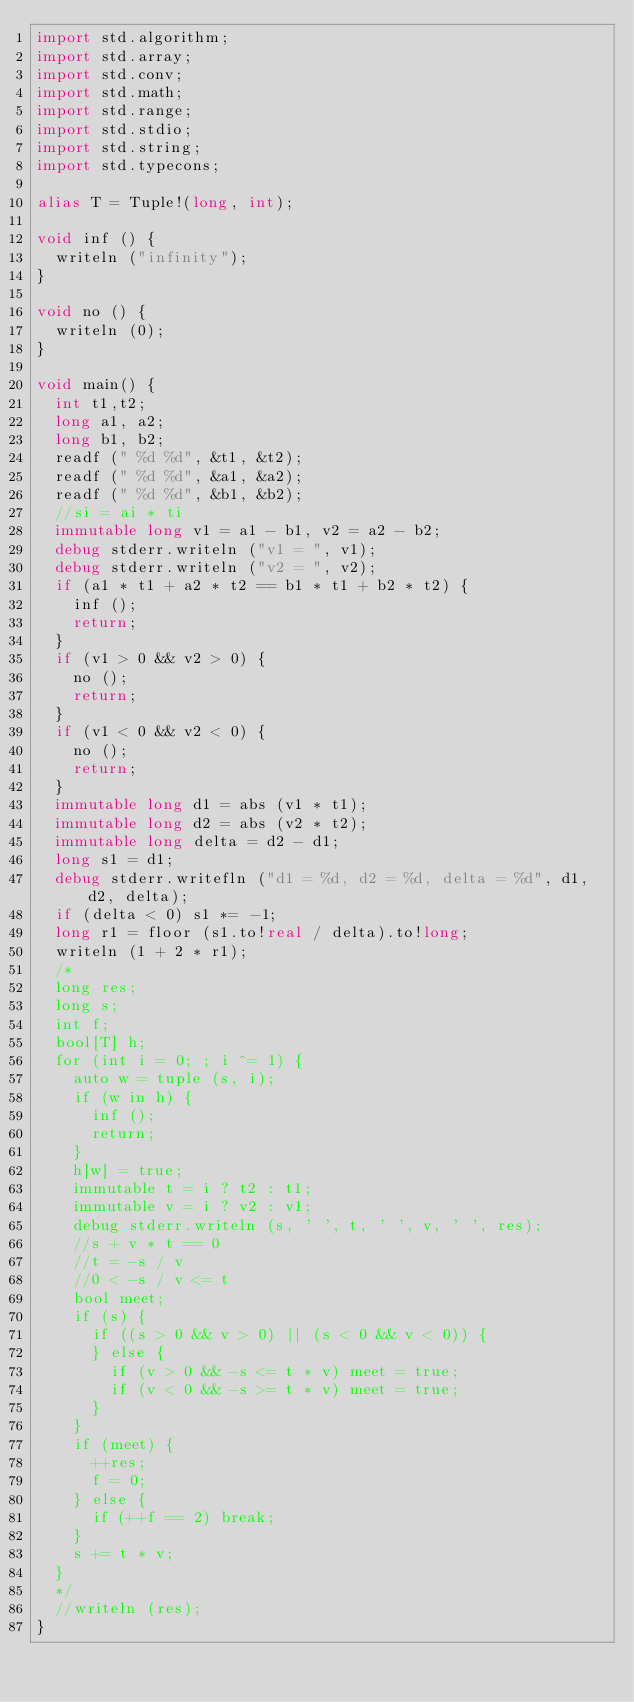Convert code to text. <code><loc_0><loc_0><loc_500><loc_500><_D_>import std.algorithm;
import std.array;
import std.conv;
import std.math;
import std.range;
import std.stdio;
import std.string;
import std.typecons;

alias T = Tuple!(long, int);

void inf () {
  writeln ("infinity");
}

void no () {
  writeln (0);
}

void main() {
  int t1,t2;
  long a1, a2;
  long b1, b2;
  readf (" %d %d", &t1, &t2);
  readf (" %d %d", &a1, &a2);
  readf (" %d %d", &b1, &b2);
  //si = ai * ti
  immutable long v1 = a1 - b1, v2 = a2 - b2;
  debug stderr.writeln ("v1 = ", v1);
  debug stderr.writeln ("v2 = ", v2);
  if (a1 * t1 + a2 * t2 == b1 * t1 + b2 * t2) {
    inf ();
    return;
  }
  if (v1 > 0 && v2 > 0) {
    no ();
    return;
  }
  if (v1 < 0 && v2 < 0) {
    no ();
    return;
  }
  immutable long d1 = abs (v1 * t1);
  immutable long d2 = abs (v2 * t2);
  immutable long delta = d2 - d1; 
  long s1 = d1;
  debug stderr.writefln ("d1 = %d, d2 = %d, delta = %d", d1, d2, delta);
  if (delta < 0) s1 *= -1;
  long r1 = floor (s1.to!real / delta).to!long;
  writeln (1 + 2 * r1);
  /*
  long res;
  long s;
  int f;
  bool[T] h;
  for (int i = 0; ; i ^= 1) {
    auto w = tuple (s, i);
    if (w in h) {
      inf ();
      return;
    }
    h[w] = true;
    immutable t = i ? t2 : t1;
    immutable v = i ? v2 : v1;
    debug stderr.writeln (s, ' ', t, ' ', v, ' ', res);
    //s + v * t == 0
    //t = -s / v
    //0 < -s / v <= t 
    bool meet;
    if (s) {
      if ((s > 0 && v > 0) || (s < 0 && v < 0)) {
      } else {
        if (v > 0 && -s <= t * v) meet = true;
        if (v < 0 && -s >= t * v) meet = true;
      }
    }
    if (meet) {
      ++res;
      f = 0;
    } else {
      if (++f == 2) break;
    }
    s += t * v; 
  }
  */
  //writeln (res);
}

</code> 